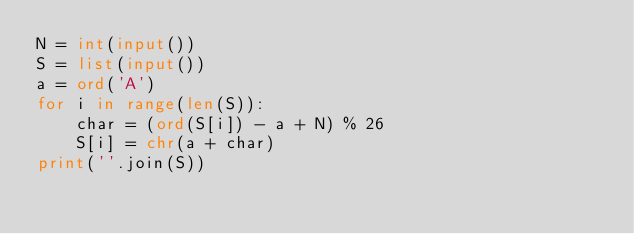Convert code to text. <code><loc_0><loc_0><loc_500><loc_500><_Python_>N = int(input())
S = list(input())
a = ord('A')
for i in range(len(S)):
    char = (ord(S[i]) - a + N) % 26
    S[i] = chr(a + char)
print(''.join(S))</code> 